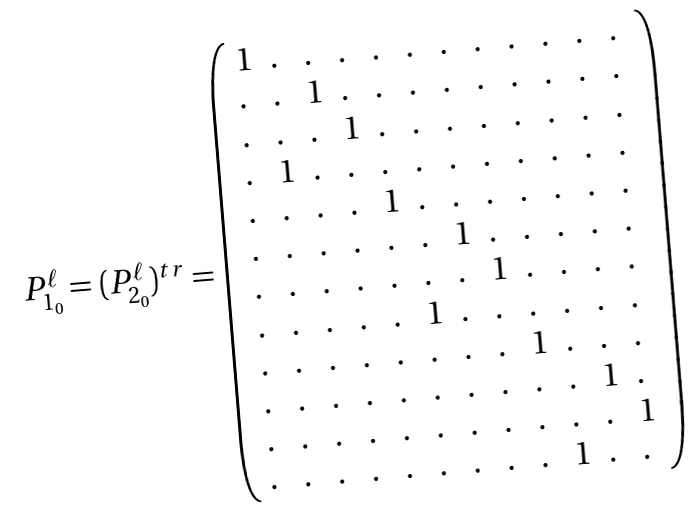Convert formula to latex. <formula><loc_0><loc_0><loc_500><loc_500>\begin{array} { c c c } P ^ { \ell } _ { 1 _ { 0 } } = ( P ^ { \ell } _ { 2 _ { 0 } } ) ^ { t r } = \left ( \begin{array} { l l l l l l l l l l l l } 1 & . & . & . & . & . & . & . & . & . & . & . \\ . & . & 1 & . & . & . & . & . & . & . & . & . \\ . & . & . & 1 & . & . & . & . & . & . & . & . \\ . & 1 & . & . & . & . & . & . & . & . & . & . \\ . & . & . & . & 1 & . & . & . & . & . & . & . \\ . & . & . & . & . & . & 1 & . & . & . & . & . \\ . & . & . & . & . & . & . & 1 & . & . & . & . \\ . & . & . & . & . & 1 & . & . & . & . & . & . \\ . & . & . & . & . & . & . & . & 1 & . & . & . \\ . & . & . & . & . & . & . & . & . & . & 1 & . \\ . & . & . & . & . & . & . & . & . & . & . & 1 \\ . & . & . & . & . & . & . & . & . & 1 & . & . \end{array} \right ) \end{array}</formula> 